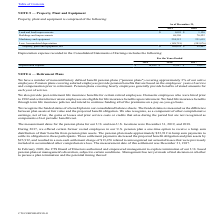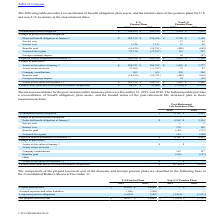According to Cts Corporation's financial document, How does the company provide pension plans that cover salaries employees? provide pension benefits that are based on the employees´ years of service and compensation prior to retirement. The document states: "loyees. Pension plans covering salaried employees provide pension benefits that are based on the employees´ years of service and compensation prior to..." Also, What did the CTS Board of Directors authorize in February 2020? authorized and empowered management to explore termination of our U.S. based pension plans at management's discretion, subject to certain conditions. The document states: "In February 2020, the CTS Board of Directors authorized and empowered management to explore termination of our U.S. based pension plans at management'..." Also, What was the accumulated benefit obligation in 2019? According to the financial document, 4,766 (in thousands). The relevant text states: "Accumulated benefit obligation $ 4,766 $ 4,595..." Also, can you calculate: What was the change in the Projected benefit obligation at January 1 between 2018 and 2019? Based on the calculation: 4,595-5,134, the result is -539 (in thousands). This is based on the information: "Accumulated benefit obligation $ 4,766 $ 4,595 ojected benefit obligation at January 1 $ 4,595 $ 5,134..." The key data points involved are: 4,595, 5,134. Also, How many years did the Interest cost exceed $150 thousand? Counting the relevant items in the document: 2019, 2018, I find 2 instances. The key data points involved are: 2018, 2019. Also, can you calculate: What was the percentage change in company contributions between 2018 and 2019? To answer this question, I need to perform calculations using the financial data. The calculation is: (145-157)/157, which equals -7.64 (percentage). This is based on the information: "Benefits paid (145) (157) Benefits paid (145) (157)..." The key data points involved are: 145, 157. 